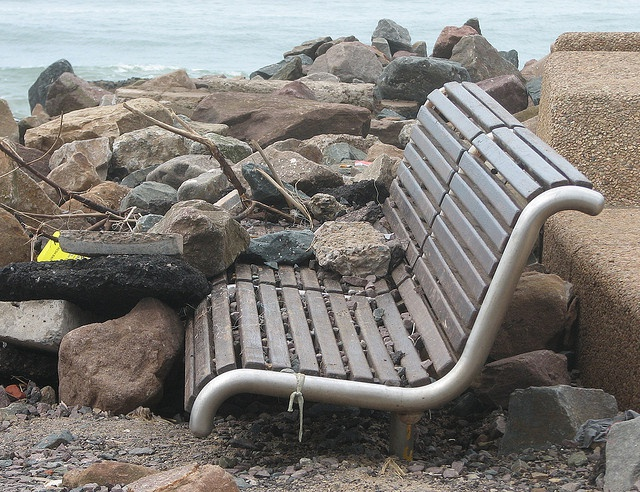Describe the objects in this image and their specific colors. I can see a bench in lightblue, darkgray, gray, lightgray, and black tones in this image. 